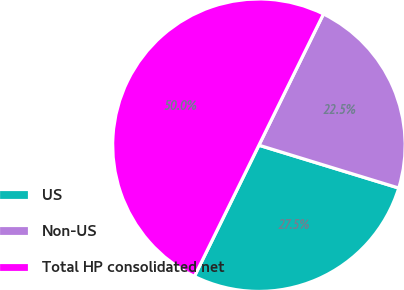<chart> <loc_0><loc_0><loc_500><loc_500><pie_chart><fcel>US<fcel>Non-US<fcel>Total HP consolidated net<nl><fcel>27.54%<fcel>22.46%<fcel>50.0%<nl></chart> 